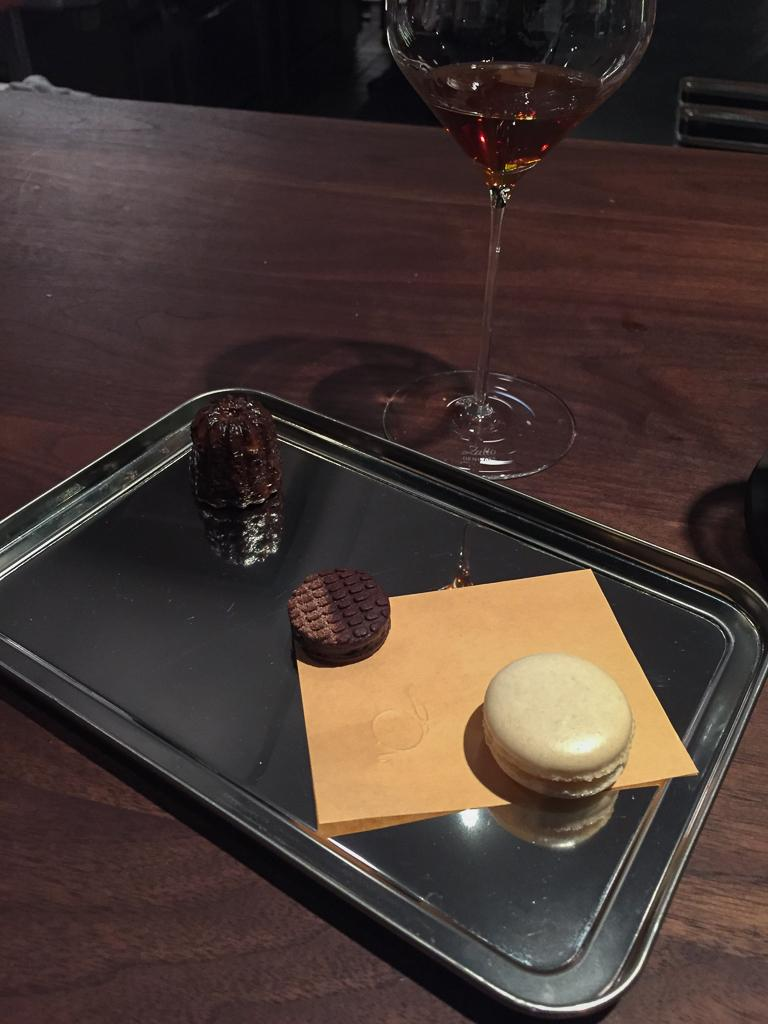What type of dessert can be seen in the image? There is a dessert in a plate in the image. What other items are present on the table in the image? There are two chocolate cookies and a wine glass on the table. What is the primary function of the wine glass in the image? The wine glass is likely used for holding a beverage, such as wine, in the image. What type of needle is used to sew the chocolate cookies in the image? There is no needle or sewing activity present in the image; it features two chocolate cookies and a dessert in a plate. 